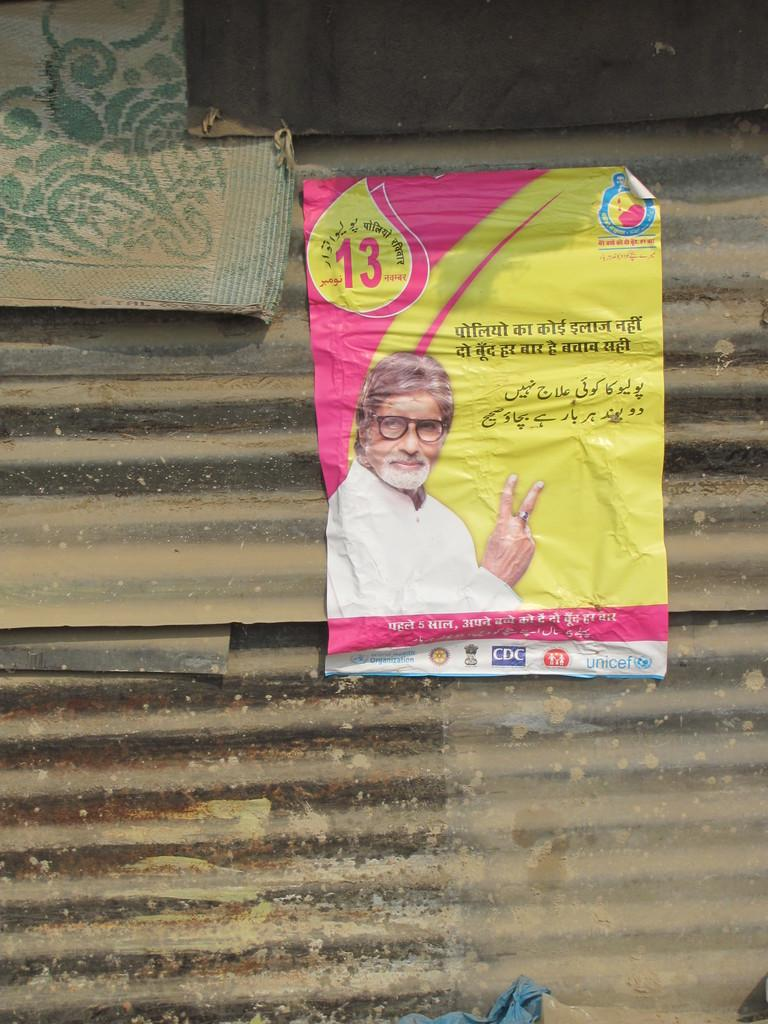What is present on the wall in the image? There is a poster in the image, which is attached to a metal wall. What is on the poster? The poster has an image of a person wearing spectacles and also has text on it. What is the material of the mat on the wall? The mat on the wall is made of a different material than the metal wall. What type of sack is being used to carry the person's elbow in the image? There is no sack or person's elbow present in the image; it only features a poster with an image of a person wearing spectacles. 